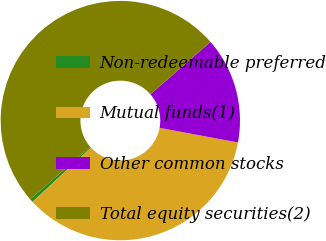Convert chart. <chart><loc_0><loc_0><loc_500><loc_500><pie_chart><fcel>Non-redeemable preferred<fcel>Mutual funds(1)<fcel>Other common stocks<fcel>Total equity securities(2)<nl><fcel>0.46%<fcel>35.19%<fcel>14.35%<fcel>50.0%<nl></chart> 